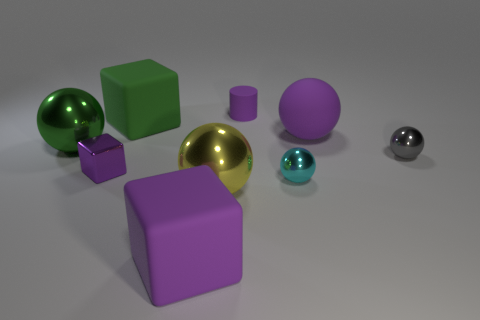Is the color of the metallic cube the same as the rubber cube in front of the green rubber object?
Your answer should be very brief. Yes. Is there a rubber cylinder of the same color as the rubber sphere?
Offer a terse response. Yes. There is a small metal object that is the same color as the cylinder; what shape is it?
Offer a terse response. Cube. The matte block that is the same color as the matte ball is what size?
Provide a short and direct response. Large. What is the shape of the shiny thing that is both to the left of the yellow metal object and on the right side of the big green shiny object?
Your response must be concise. Cube. What number of other things are there of the same shape as the gray object?
Give a very brief answer. 4. The small matte thing behind the rubber block that is behind the tiny thing in front of the small cube is what shape?
Offer a very short reply. Cylinder. What number of things are big shiny cylinders or things that are behind the rubber sphere?
Make the answer very short. 2. There is a tiny thing left of the yellow metallic object; is its shape the same as the small thing behind the large green metallic object?
Provide a short and direct response. No. What number of objects are small brown cubes or yellow metallic balls?
Keep it short and to the point. 1. 